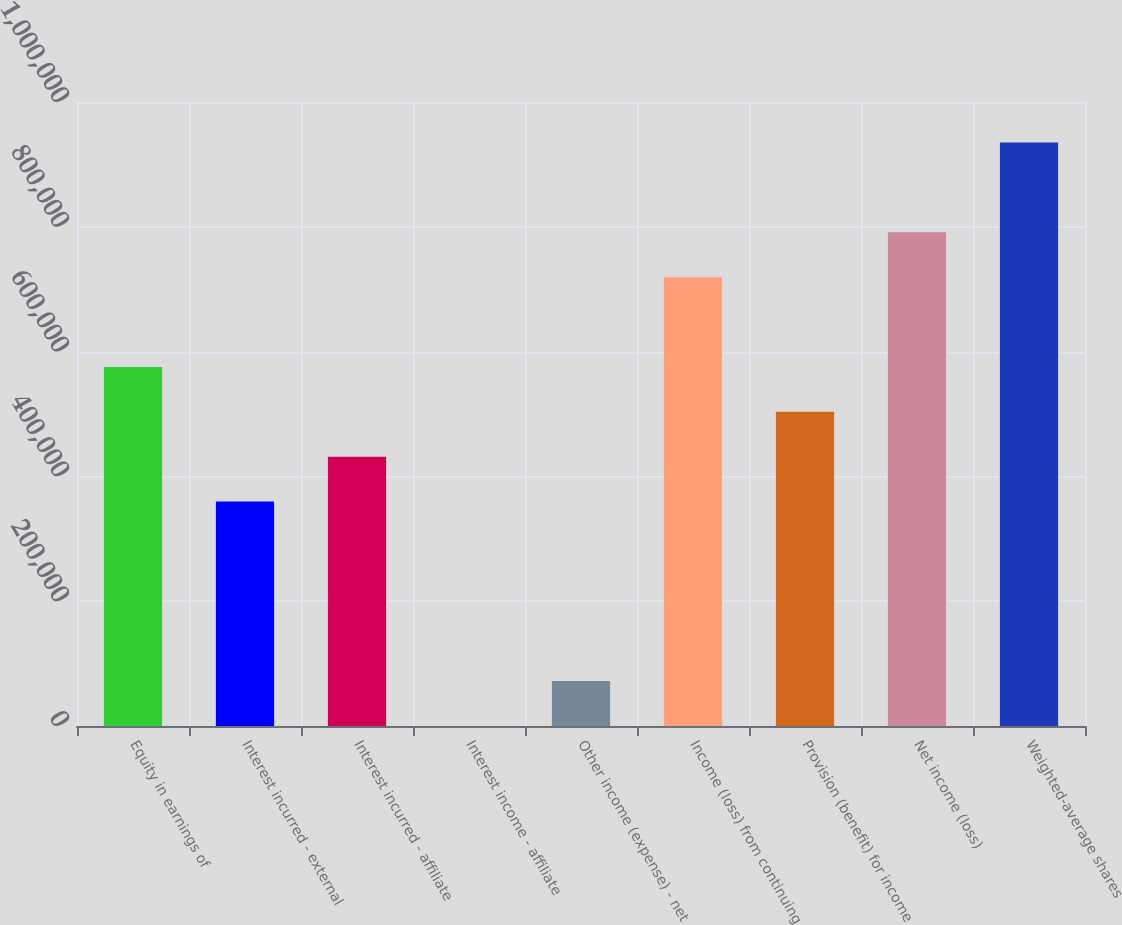Convert chart. <chart><loc_0><loc_0><loc_500><loc_500><bar_chart><fcel>Equity in earnings of<fcel>Interest incurred - external<fcel>Interest incurred - affiliate<fcel>Interest income - affiliate<fcel>Other income (expense) - net<fcel>Income (loss) from continuing<fcel>Provision (benefit) for income<fcel>Net income (loss)<fcel>Weighted-average shares<nl><fcel>575462<fcel>359668<fcel>431599<fcel>10<fcel>71941.5<fcel>719325<fcel>503530<fcel>791256<fcel>935120<nl></chart> 